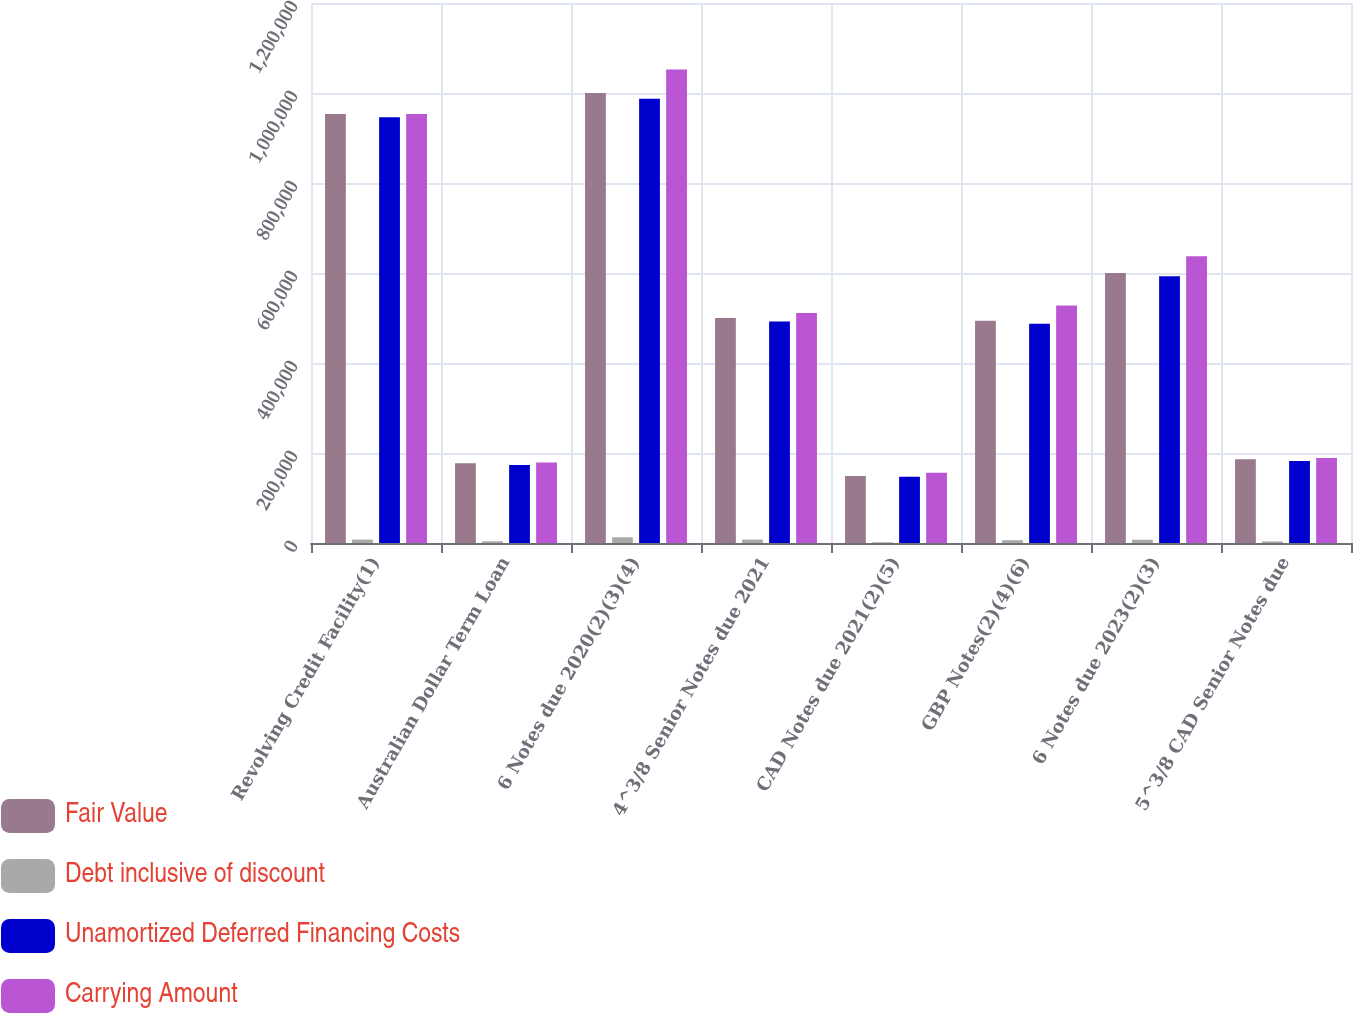Convert chart. <chart><loc_0><loc_0><loc_500><loc_500><stacked_bar_chart><ecel><fcel>Revolving Credit Facility(1)<fcel>Australian Dollar Term Loan<fcel>6 Notes due 2020(2)(3)(4)<fcel>4^3/8 Senior Notes due 2021<fcel>CAD Notes due 2021(2)(5)<fcel>GBP Notes(2)(4)(6)<fcel>6 Notes due 2023(2)(3)<fcel>5^3/8 CAD Senior Notes due<nl><fcel>Fair Value<fcel>953548<fcel>177198<fcel>1e+06<fcel>500000<fcel>148792<fcel>493648<fcel>600000<fcel>185990<nl><fcel>Debt inclusive of discount<fcel>7530<fcel>3774<fcel>12730<fcel>7593<fcel>1635<fcel>6214<fcel>7322<fcel>3498<nl><fcel>Unamortized Deferred Financing Costs<fcel>946018<fcel>173424<fcel>987270<fcel>492407<fcel>147157<fcel>487434<fcel>592678<fcel>182492<nl><fcel>Carrying Amount<fcel>953548<fcel>178923<fcel>1.0525e+06<fcel>511250<fcel>155860<fcel>527562<fcel>637500<fcel>188780<nl></chart> 